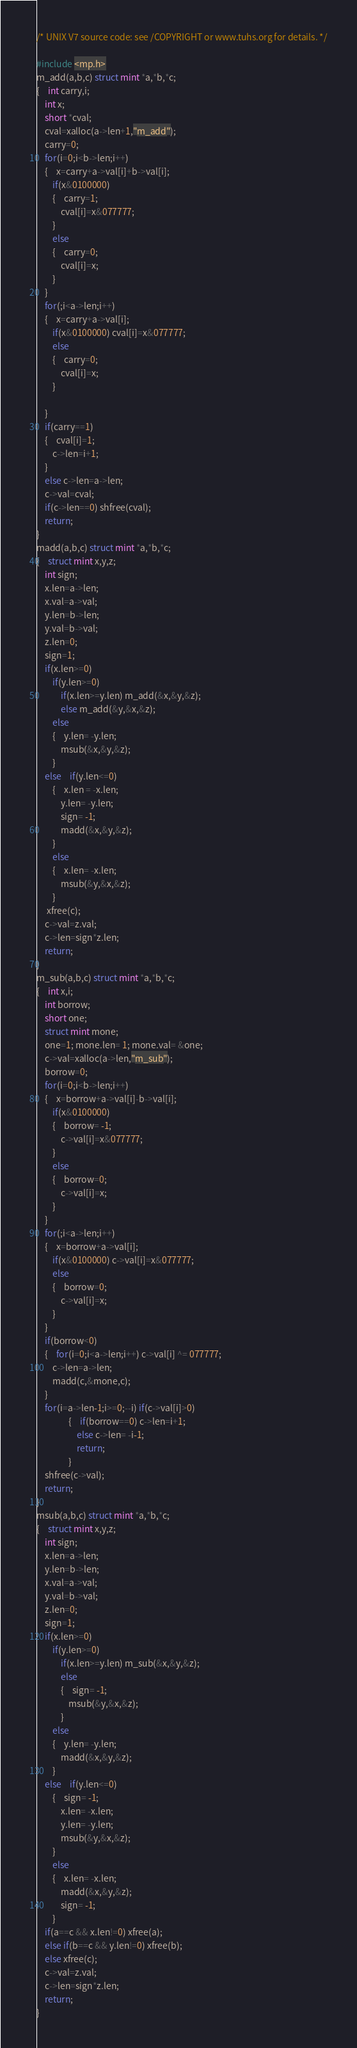<code> <loc_0><loc_0><loc_500><loc_500><_C_>/* UNIX V7 source code: see /COPYRIGHT or www.tuhs.org for details. */

#include <mp.h>
m_add(a,b,c) struct mint *a,*b,*c;
{	int carry,i;
	int x;
	short *cval;
	cval=xalloc(a->len+1,"m_add");
	carry=0;
	for(i=0;i<b->len;i++)
	{	x=carry+a->val[i]+b->val[i];
		if(x&0100000)
		{	carry=1;
			cval[i]=x&077777;
		}
		else
		{	carry=0;
			cval[i]=x;
		}
	}
	for(;i<a->len;i++)
	{	x=carry+a->val[i];
		if(x&0100000) cval[i]=x&077777;
		else
		{	carry=0;
			cval[i]=x;
		}

	}
	if(carry==1)
	{	cval[i]=1;
		c->len=i+1;
	}
	else c->len=a->len;
	c->val=cval;
	if(c->len==0) shfree(cval);
	return;
}
madd(a,b,c) struct mint *a,*b,*c;
{	struct mint x,y,z;
	int sign;
	x.len=a->len;
	x.val=a->val;
	y.len=b->len;
	y.val=b->val;
	z.len=0;
	sign=1;
	if(x.len>=0)
		if(y.len>=0)
			if(x.len>=y.len) m_add(&x,&y,&z);
			else m_add(&y,&x,&z);
		else
		{	y.len= -y.len;
			msub(&x,&y,&z);
		}
	else	if(y.len<=0)
		{	x.len = -x.len;
			y.len= -y.len;
			sign= -1;
			madd(&x,&y,&z);
		}
		else
		{	x.len= -x.len;
			msub(&y,&x,&z);
		}
	 xfree(c);
	c->val=z.val;
	c->len=sign*z.len;
	return;
}
m_sub(a,b,c) struct mint *a,*b,*c;
{	int x,i;
	int borrow;
	short one;
	struct mint mone;
	one=1; mone.len= 1; mone.val= &one;
	c->val=xalloc(a->len,"m_sub");
	borrow=0;
	for(i=0;i<b->len;i++)
	{	x=borrow+a->val[i]-b->val[i];
		if(x&0100000)
		{	borrow= -1;
			c->val[i]=x&077777;
		}
		else
		{	borrow=0;
			c->val[i]=x;
		}
	}
	for(;i<a->len;i++)
	{	x=borrow+a->val[i];
		if(x&0100000) c->val[i]=x&077777;
		else
		{	borrow=0;
			c->val[i]=x;
		}
	}
	if(borrow<0)
	{	for(i=0;i<a->len;i++) c->val[i] ^= 077777;
		c->len=a->len;
		madd(c,&mone,c);
	}
	for(i=a->len-1;i>=0;--i) if(c->val[i]>0)
				{	if(borrow==0) c->len=i+1;
					else c->len= -i-1;
					return;
				}
	shfree(c->val);
	return;
}
msub(a,b,c) struct mint *a,*b,*c;
{	struct mint x,y,z;
	int sign;
	x.len=a->len;
	y.len=b->len;
	x.val=a->val;
	y.val=b->val;
	z.len=0;
	sign=1;
	if(x.len>=0)
		if(y.len>=0)
			if(x.len>=y.len) m_sub(&x,&y,&z);
			else
			{	sign= -1;
				msub(&y,&x,&z);
			}
		else
		{	y.len= -y.len;
			madd(&x,&y,&z);
		}
	else	if(y.len<=0)
		{	sign= -1;
			x.len= -x.len;
			y.len= -y.len;
			msub(&y,&x,&z);
		}
		else
		{	x.len= -x.len;
			madd(&x,&y,&z);
			sign= -1;
		}
	if(a==c && x.len!=0) xfree(a);
	else if(b==c && y.len!=0) xfree(b);
	else xfree(c);
	c->val=z.val;
	c->len=sign*z.len;
	return;
}
</code> 